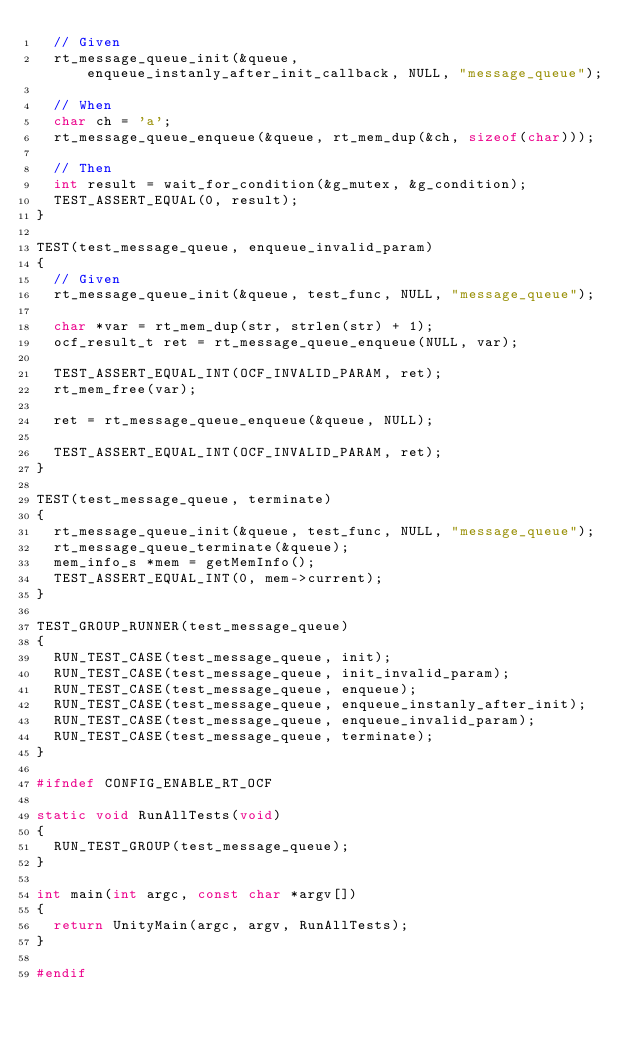<code> <loc_0><loc_0><loc_500><loc_500><_C_>	// Given
	rt_message_queue_init(&queue, enqueue_instanly_after_init_callback, NULL, "message_queue");

	// When
	char ch = 'a';
	rt_message_queue_enqueue(&queue, rt_mem_dup(&ch, sizeof(char)));

	// Then
	int result = wait_for_condition(&g_mutex, &g_condition);
	TEST_ASSERT_EQUAL(0, result);
}

TEST(test_message_queue, enqueue_invalid_param)
{
	// Given
	rt_message_queue_init(&queue, test_func, NULL, "message_queue");

	char *var = rt_mem_dup(str, strlen(str) + 1);
	ocf_result_t ret = rt_message_queue_enqueue(NULL, var);

	TEST_ASSERT_EQUAL_INT(OCF_INVALID_PARAM, ret);
	rt_mem_free(var);

	ret = rt_message_queue_enqueue(&queue, NULL);

	TEST_ASSERT_EQUAL_INT(OCF_INVALID_PARAM, ret);
}

TEST(test_message_queue, terminate)
{
	rt_message_queue_init(&queue, test_func, NULL, "message_queue");
	rt_message_queue_terminate(&queue);
	mem_info_s *mem = getMemInfo();
	TEST_ASSERT_EQUAL_INT(0, mem->current);
}

TEST_GROUP_RUNNER(test_message_queue)
{
	RUN_TEST_CASE(test_message_queue, init);
	RUN_TEST_CASE(test_message_queue, init_invalid_param);
	RUN_TEST_CASE(test_message_queue, enqueue);
	RUN_TEST_CASE(test_message_queue, enqueue_instanly_after_init);
	RUN_TEST_CASE(test_message_queue, enqueue_invalid_param);
	RUN_TEST_CASE(test_message_queue, terminate);
}

#ifndef CONFIG_ENABLE_RT_OCF

static void RunAllTests(void)
{
	RUN_TEST_GROUP(test_message_queue);
}

int main(int argc, const char *argv[])
{
	return UnityMain(argc, argv, RunAllTests);
}

#endif
</code> 